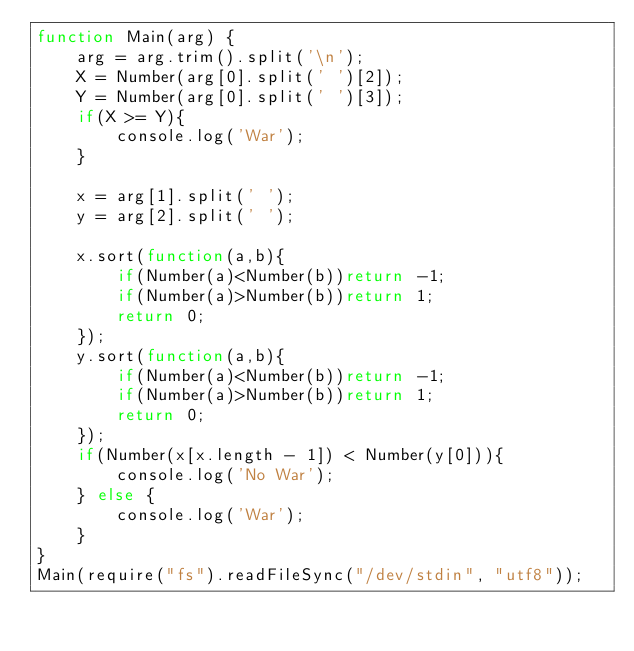Convert code to text. <code><loc_0><loc_0><loc_500><loc_500><_JavaScript_>function Main(arg) {
    arg = arg.trim().split('\n');
    X = Number(arg[0].split(' ')[2]);
    Y = Number(arg[0].split(' ')[3]);
    if(X >= Y){
        console.log('War');
    }
  
    x = arg[1].split(' ');
    y = arg[2].split(' ');
    
    x.sort(function(a,b){
        if(Number(a)<Number(b))return -1;
        if(Number(a)>Number(b))return 1;
        return 0;
    });
    y.sort(function(a,b){
        if(Number(a)<Number(b))return -1;
        if(Number(a)>Number(b))return 1;
        return 0;
    });
    if(Number(x[x.length - 1]) < Number(y[0])){
        console.log('No War');
    } else {
        console.log('War');
    }
}
Main(require("fs").readFileSync("/dev/stdin", "utf8"));</code> 